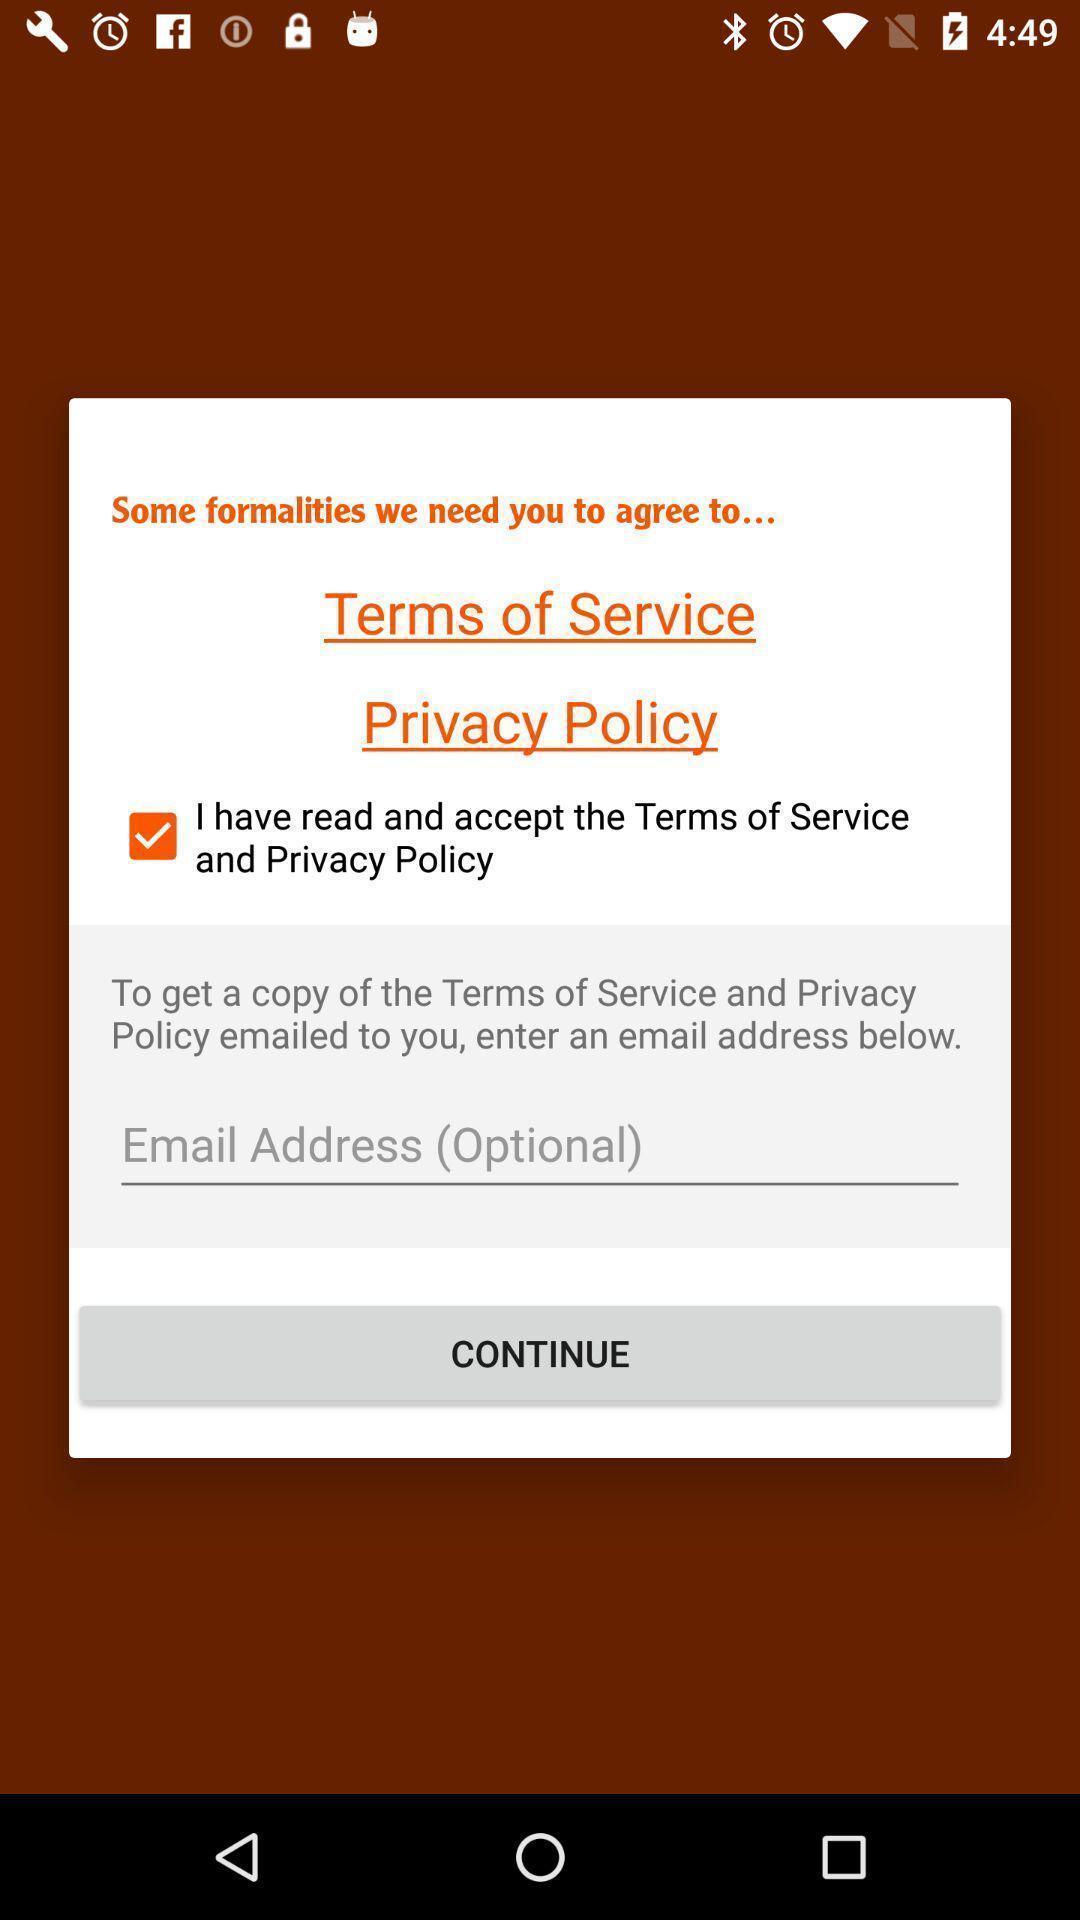Please provide a description for this image. Pop-up displaying email address and terms and privacy to agree. 